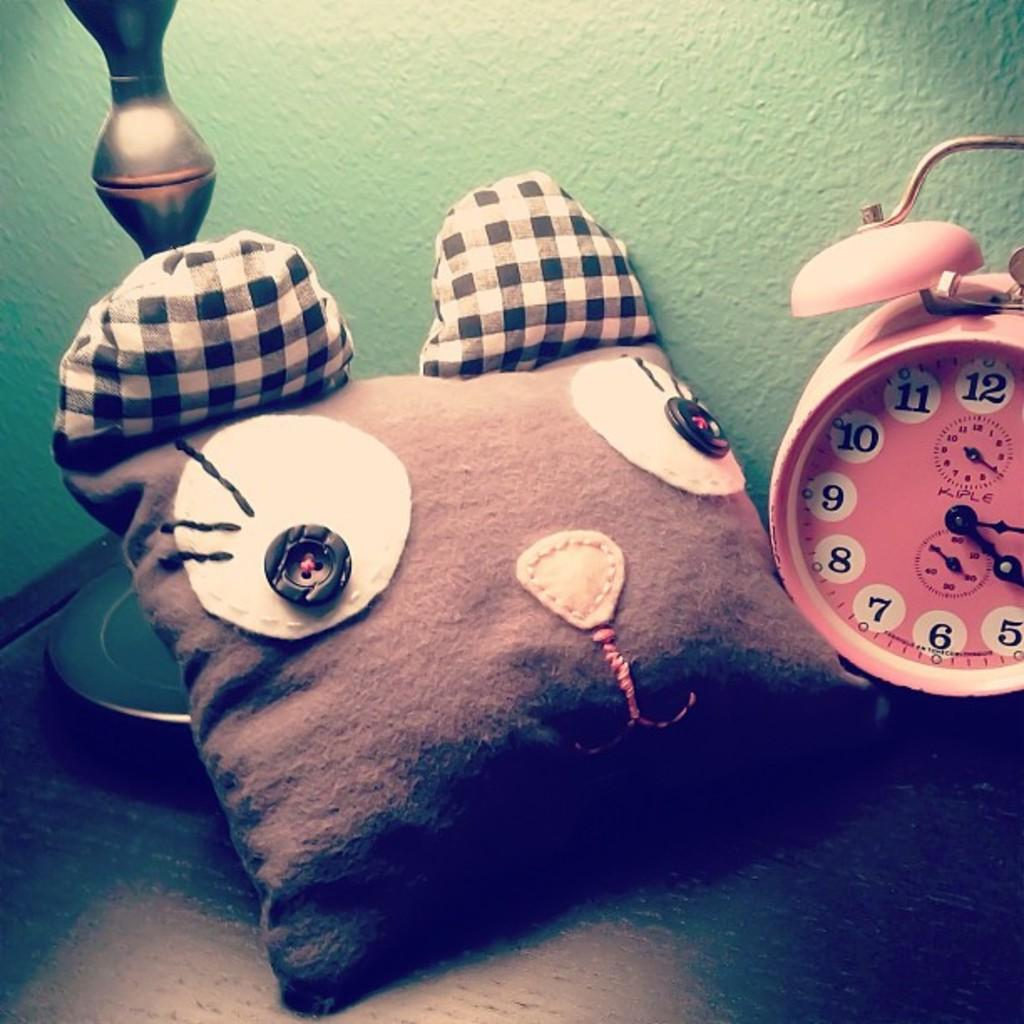What object can be seen in the image that is typically used for comfort or rest? There is a pillow in the image. What object in the image can be used to tell time? There is a timepiece in the image. Where are the pillow and timepiece located in the image? Both the pillow and timepiece are on a surface. What can be seen in the background of the image? There is a wall visible in the background of the image. What type of doll is celebrating its birthday on the pillow in the image? There is no doll present in the image, and no birthday celebration is depicted. 